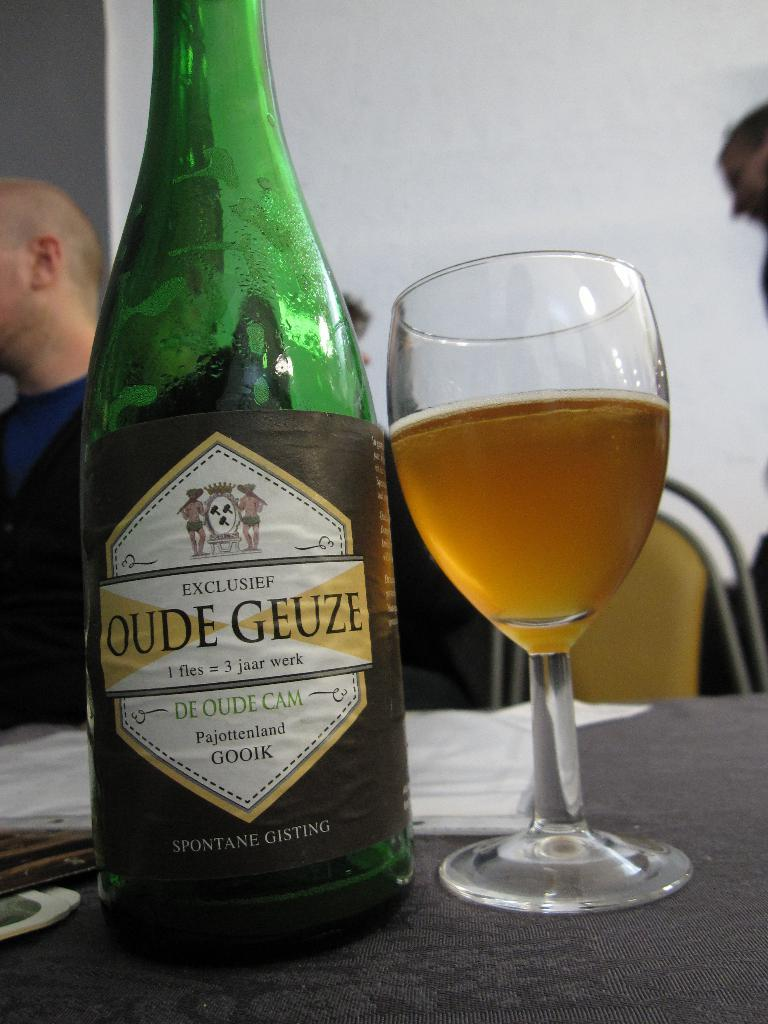<image>
Share a concise interpretation of the image provided. a green glass bottle of oude geuze gisting and a half full glass 